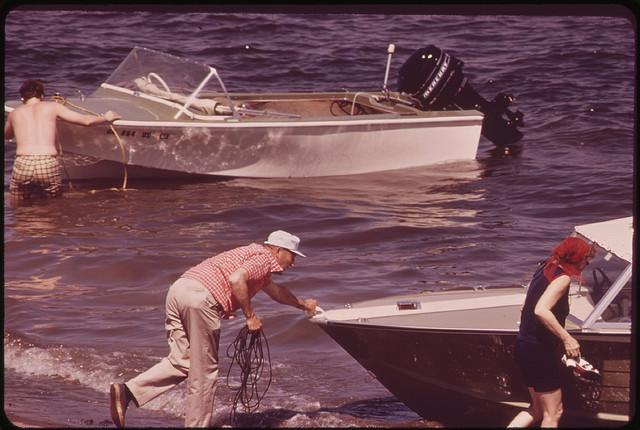Was this photo taken recently?
Quick response, please. No. Does every person have a shirt on?
Quick response, please. Yes. Is the man going to fall?
Concise answer only. No. 